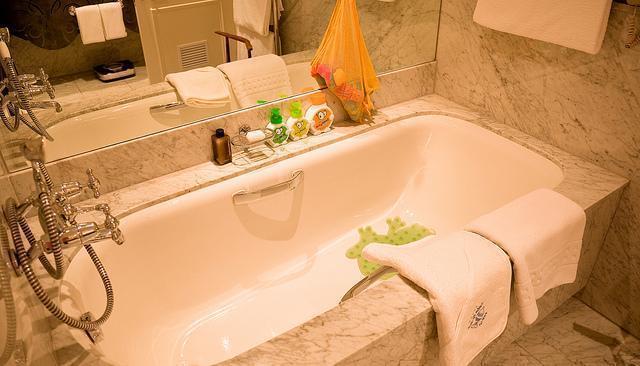Who likely uses this bathtub?
Indicate the correct response and explain using: 'Answer: answer
Rationale: rationale.'
Options: Adults, animals, children, teenagers. Answer: children.
Rationale: There are small bottles. 